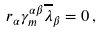Convert formula to latex. <formula><loc_0><loc_0><loc_500><loc_500>r _ { \alpha } \gamma _ { m } ^ { \alpha \beta } \overline { \lambda } _ { \beta } = 0 \, ,</formula> 